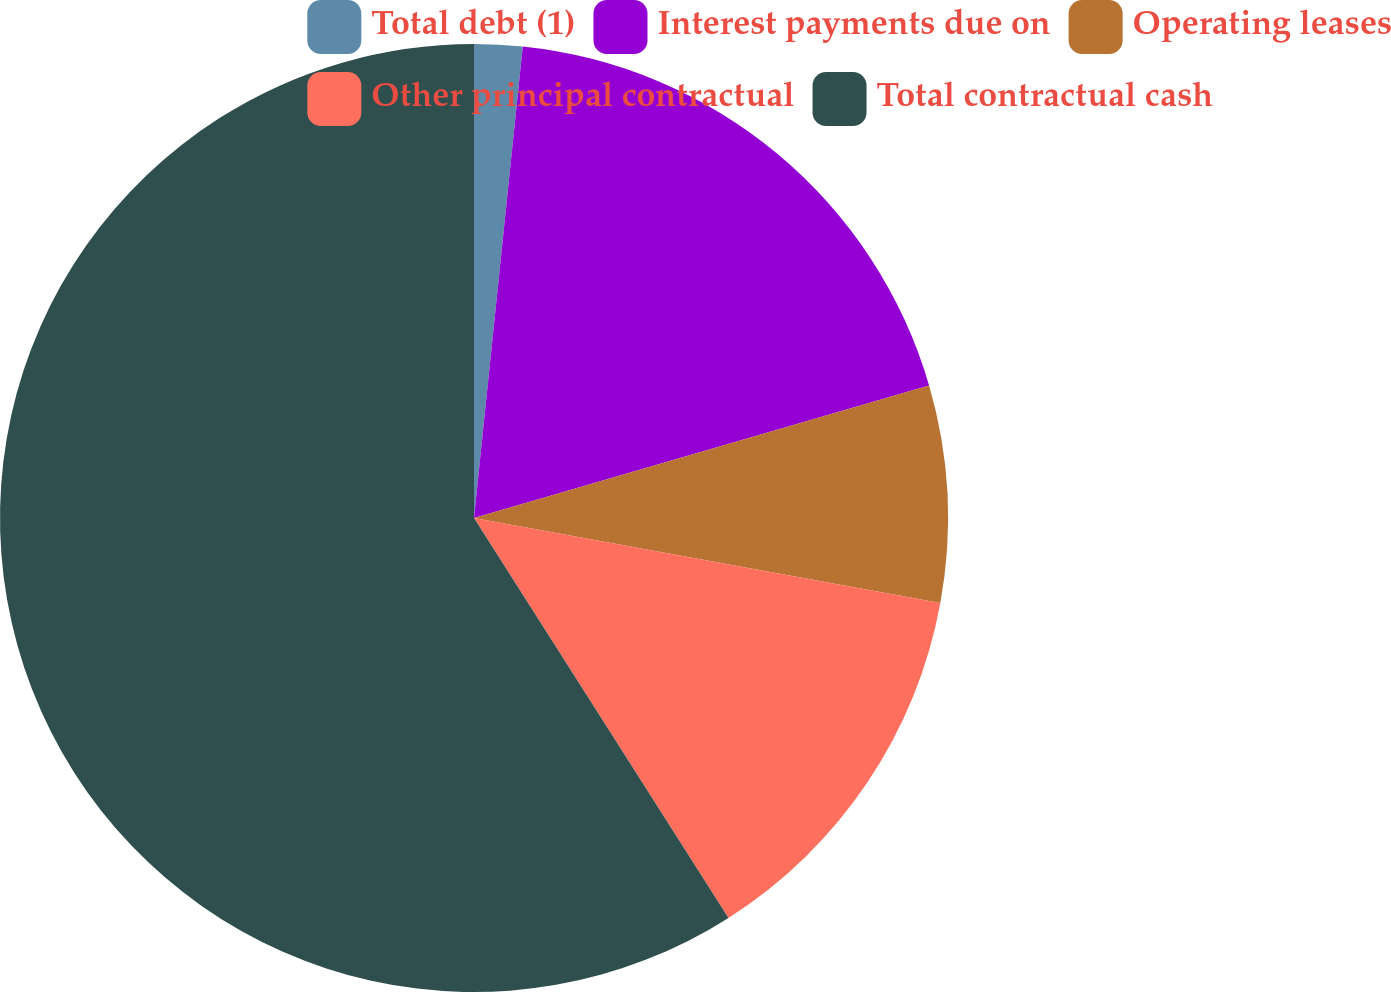<chart> <loc_0><loc_0><loc_500><loc_500><pie_chart><fcel>Total debt (1)<fcel>Interest payments due on<fcel>Operating leases<fcel>Other principal contractual<fcel>Total contractual cash<nl><fcel>1.64%<fcel>18.85%<fcel>7.38%<fcel>13.11%<fcel>59.02%<nl></chart> 